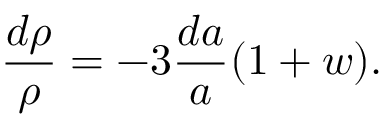Convert formula to latex. <formula><loc_0><loc_0><loc_500><loc_500>{ \frac { d \rho } { \rho } } = - 3 { \frac { d a } { a } } ( 1 + w ) .</formula> 